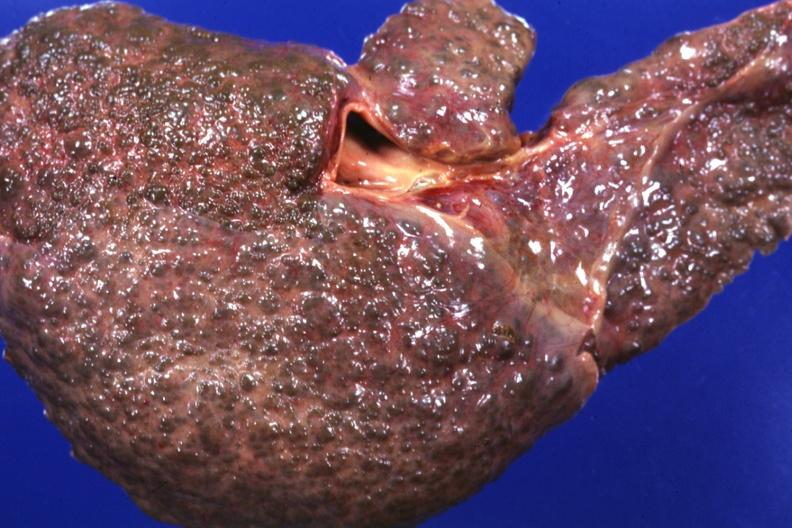s glioma present?
Answer the question using a single word or phrase. No 